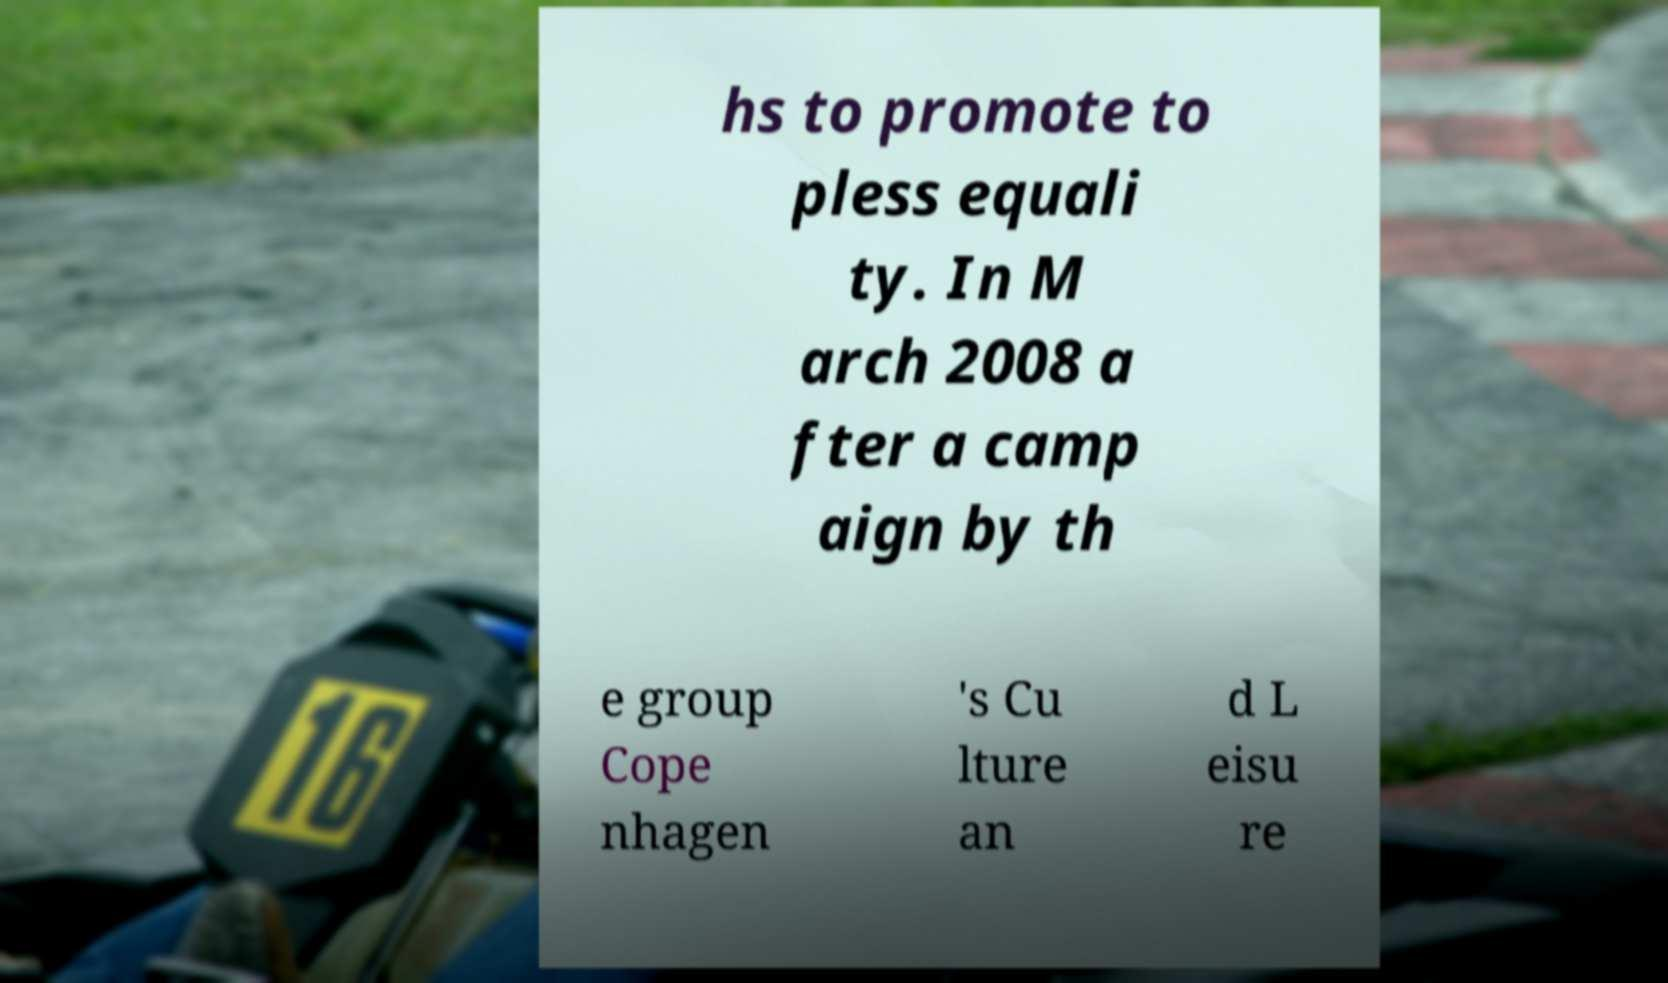Please identify and transcribe the text found in this image. hs to promote to pless equali ty. In M arch 2008 a fter a camp aign by th e group Cope nhagen 's Cu lture an d L eisu re 